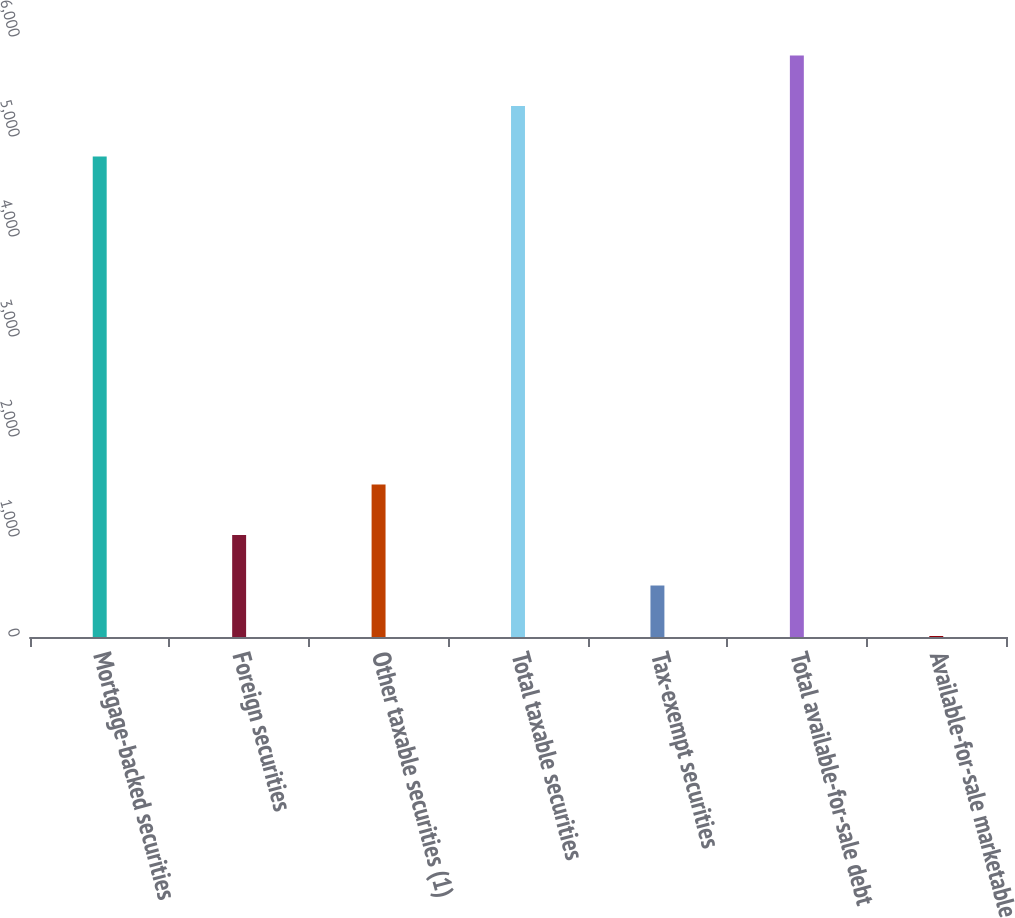<chart> <loc_0><loc_0><loc_500><loc_500><bar_chart><fcel>Mortgage-backed securities<fcel>Foreign securities<fcel>Other taxable securities (1)<fcel>Total taxable securities<fcel>Tax-exempt securities<fcel>Total available-for-sale debt<fcel>Available-for-sale marketable<nl><fcel>4804<fcel>1019.8<fcel>1524.7<fcel>5308.9<fcel>514.9<fcel>5813.8<fcel>10<nl></chart> 